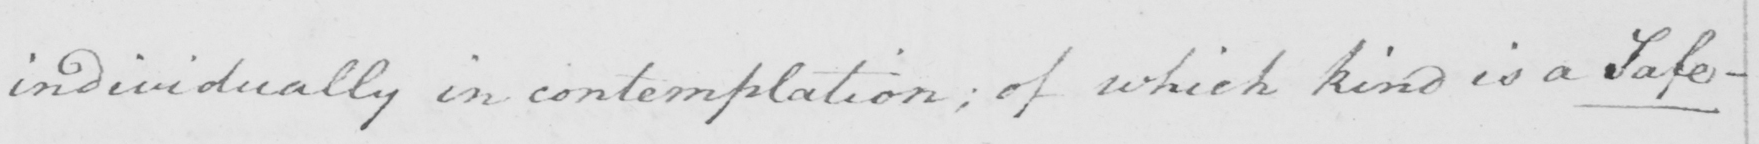Transcribe the text shown in this historical manuscript line. individually in contemplation ; of which kind is a Safe- 